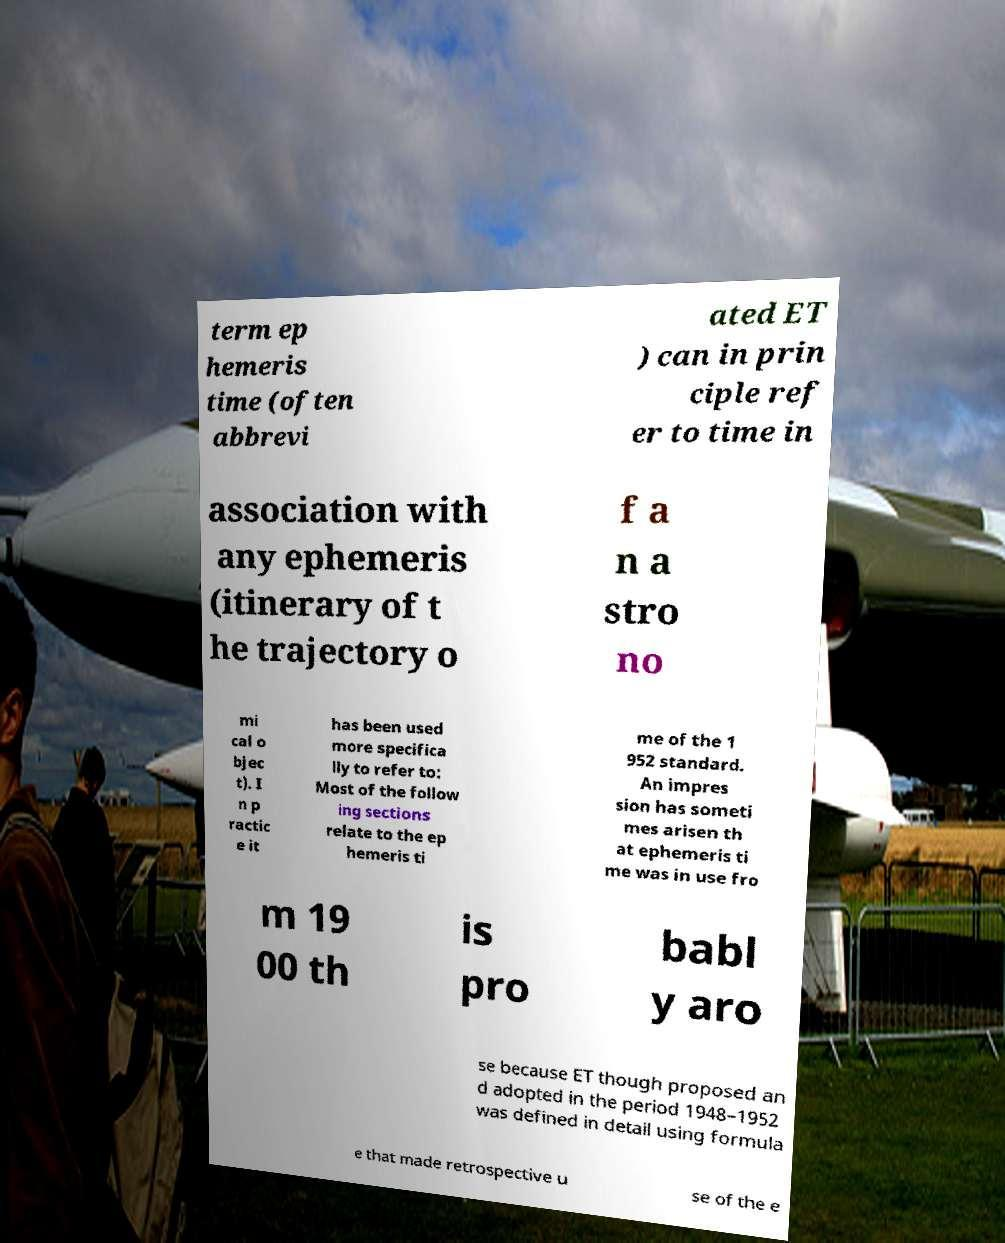Please read and relay the text visible in this image. What does it say? term ep hemeris time (often abbrevi ated ET ) can in prin ciple ref er to time in association with any ephemeris (itinerary of t he trajectory o f a n a stro no mi cal o bjec t). I n p ractic e it has been used more specifica lly to refer to: Most of the follow ing sections relate to the ep hemeris ti me of the 1 952 standard. An impres sion has someti mes arisen th at ephemeris ti me was in use fro m 19 00 th is pro babl y aro se because ET though proposed an d adopted in the period 1948–1952 was defined in detail using formula e that made retrospective u se of the e 